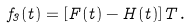<formula> <loc_0><loc_0><loc_500><loc_500>f _ { 3 } ( t ) = [ F ( t ) - H ( t ) ] T \, .</formula> 